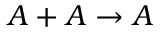Convert formula to latex. <formula><loc_0><loc_0><loc_500><loc_500>A + A \rightarrow A</formula> 